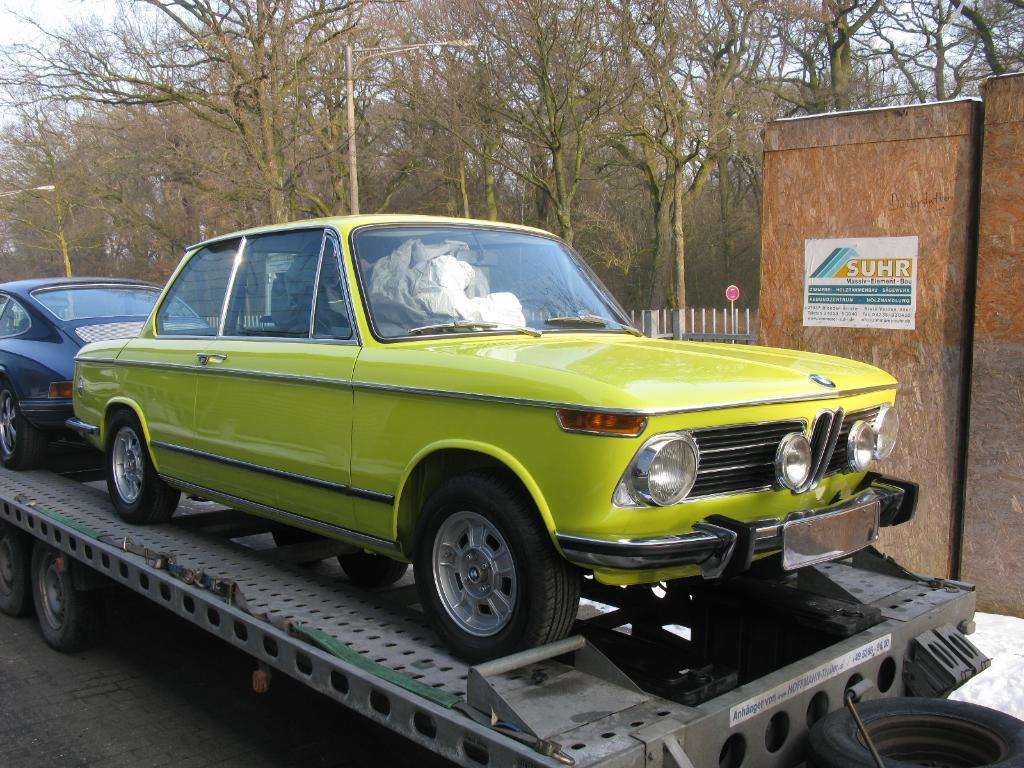What is the main subject of the image? The main subject of the image is cars on a truck in the center of the image. What can be seen in the background of the image? In the background of the image, there are poles, trees, fencing, and the sky. Can you describe the setting of the image? The image appears to be set in an outdoor area with a truck carrying cars, surrounded by natural elements like trees and poles, and man-made structures like fencing. What type of metal is used to construct the crib in the image? There is no crib present in the image; it features a truck carrying cars and various elements in the background. 